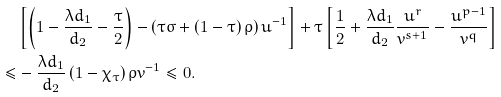<formula> <loc_0><loc_0><loc_500><loc_500>& \left [ \left ( 1 - \frac { \lambda d _ { 1 } } { d _ { 2 } } - \frac { \tau } { 2 } \right ) - \left ( \tau \sigma + \left ( 1 - \tau \right ) \rho \right ) u ^ { - 1 } \right ] + \tau \left [ \frac { 1 } { 2 } + \frac { \lambda d _ { 1 } } { d _ { 2 } } \frac { u ^ { r } } { v ^ { s + 1 } } - \frac { u ^ { p - 1 } } { v ^ { q } } \right ] \\ \leq & - \frac { \lambda d _ { 1 } } { d _ { 2 } } \left ( 1 - \chi _ { \tau } \right ) \rho v ^ { - 1 } \leq 0 .</formula> 